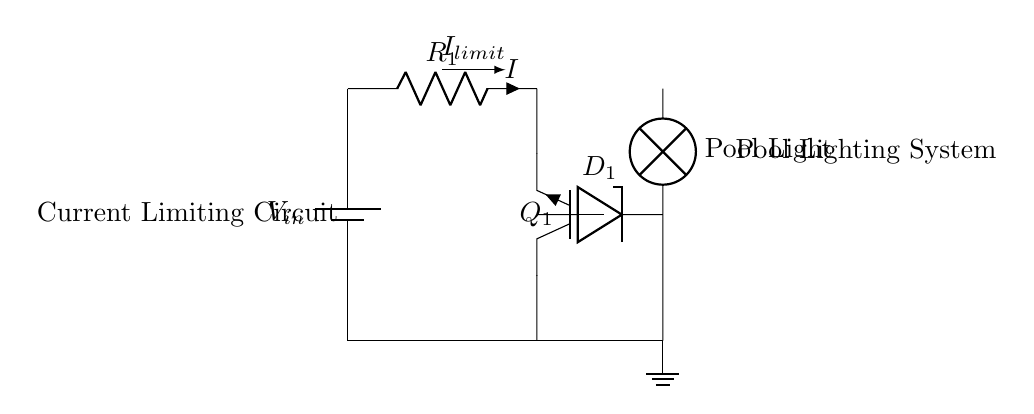What is the type of transistor used in this circuit? The circuit uses an NPN transistor, indicated by the designation "Q1" and the symbol shown. NPN transistors are commonly used for current amplification in circuits.
Answer: NPN What does the Zener diode do in this circuit? The Zener diode (D1) is connected across the output to limit the voltage across the load, ensuring that it does not exceed a certain level, which protects the pool lighting.
Answer: Voltage regulation What is the function of the resistor R1? Resistor R1 is used for current limiting; it helps to prevent excessive current through the transistor and the load, ensuring safe operation of the pool light.
Answer: Current limiting What component serves as the load in this circuit? The load is represented by the "Pool Light" symbol, indicating that the circuit is designed to power a lighting system specifically for the pool area.
Answer: Pool Light What is the direction of current flow indicated in the diagram? The circuit shows the current flow direction, indicated by the arrow above the resistor, moving from the battery through R1, then through the transistor, and finally powering the lamp.
Answer: Left to right How does the Zener diode affect current flow? The Zener diode allows current to flow in the forward direction while clamping the voltage to its breakdown voltage when reverse-biased, thus protecting the circuit from over-voltage conditions.
Answer: Current clamping 